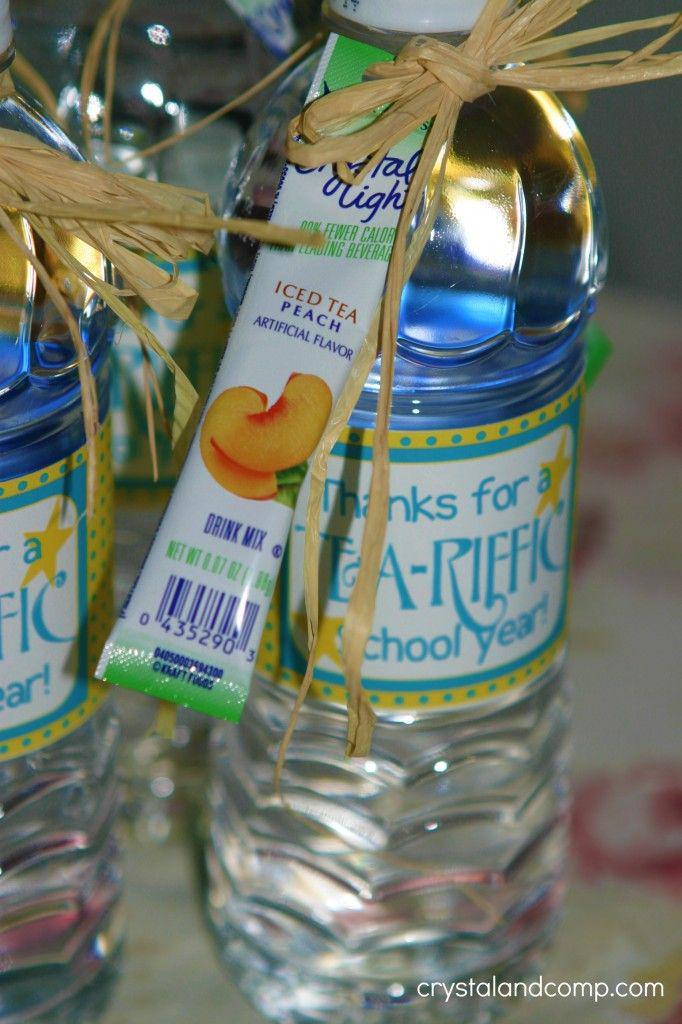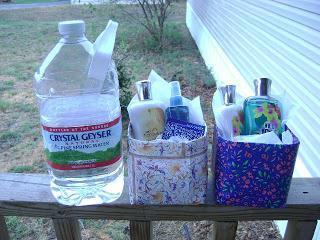The first image is the image on the left, the second image is the image on the right. For the images shown, is this caption "At least 12 water bottles are visible in one or more images." true? Answer yes or no. No. 